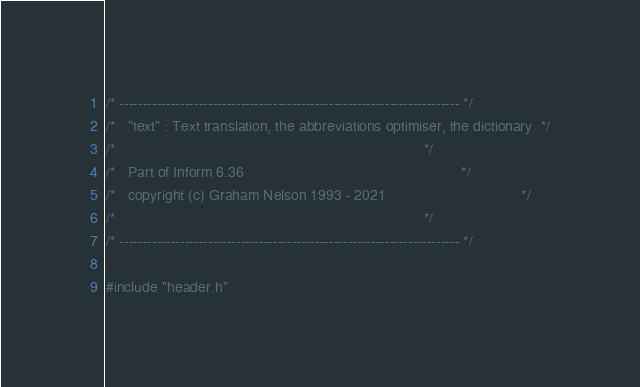<code> <loc_0><loc_0><loc_500><loc_500><_C_>/* ------------------------------------------------------------------------- */
/*   "text" : Text translation, the abbreviations optimiser, the dictionary  */
/*                                                                           */
/*   Part of Inform 6.36                                                     */
/*   copyright (c) Graham Nelson 1993 - 2021                                 */
/*                                                                           */
/* ------------------------------------------------------------------------- */

#include "header.h"
</code> 